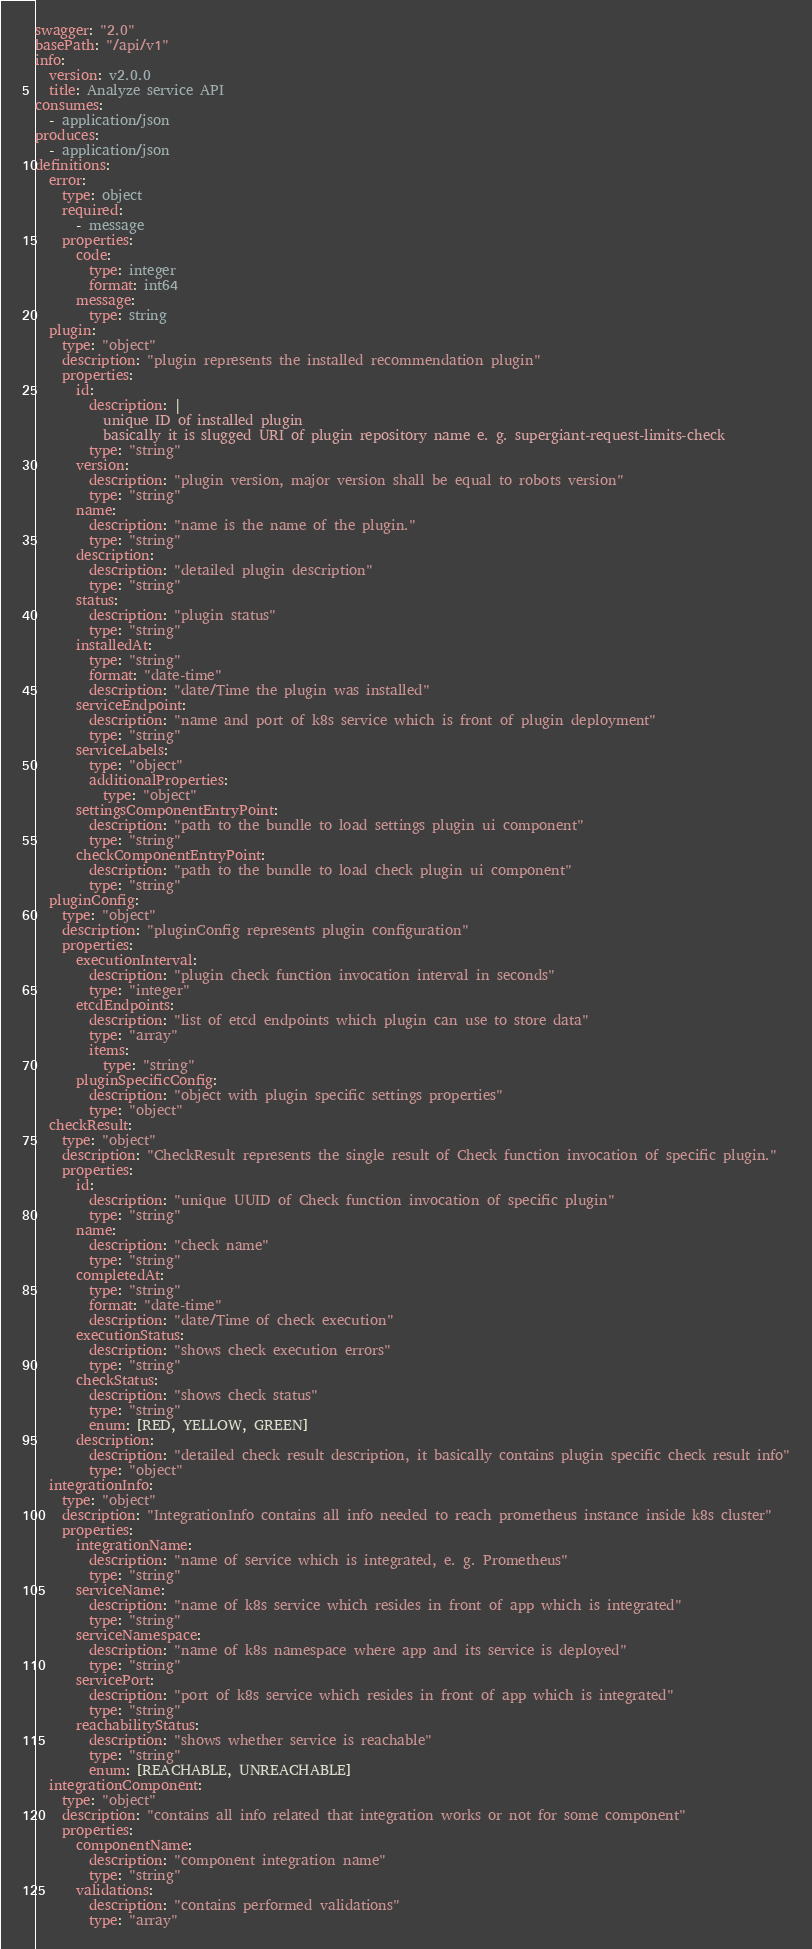<code> <loc_0><loc_0><loc_500><loc_500><_YAML_>swagger: "2.0"
basePath: "/api/v1"
info:
  version: v2.0.0
  title: Analyze service API
consumes:
  - application/json
produces:
  - application/json
definitions:
  error:
    type: object
    required:
      - message
    properties:
      code:
        type: integer
        format: int64
      message:
        type: string
  plugin:
    type: "object"
    description: "plugin represents the installed recommendation plugin"
    properties:
      id:
        description: |
          unique ID of installed plugin
          basically it is slugged URI of plugin repository name e. g. supergiant-request-limits-check
        type: "string"
      version:
        description: "plugin version, major version shall be equal to robots version"
        type: "string"
      name:
        description: "name is the name of the plugin."
        type: "string"
      description:
        description: "detailed plugin description"
        type: "string"
      status:
        description: "plugin status"
        type: "string"
      installedAt:
        type: "string"
        format: "date-time"
        description: "date/Time the plugin was installed"
      serviceEndpoint:
        description: "name and port of k8s service which is front of plugin deployment"
        type: "string"
      serviceLabels:
        type: "object"
        additionalProperties:
          type: "object"
      settingsComponentEntryPoint:
        description: "path to the bundle to load settings plugin ui component"
        type: "string"
      checkComponentEntryPoint:
        description: "path to the bundle to load check plugin ui component"
        type: "string"
  pluginConfig:
    type: "object"
    description: "pluginConfig represents plugin configuration"
    properties:
      executionInterval:
        description: "plugin check function invocation interval in seconds"
        type: "integer"
      etcdEndpoints:
        description: "list of etcd endpoints which plugin can use to store data"
        type: "array"
        items:
          type: "string"
      pluginSpecificConfig:
        description: "object with plugin specific settings properties"
        type: "object"
  checkResult:
    type: "object"
    description: "CheckResult represents the single result of Check function invocation of specific plugin."
    properties:
      id:
        description: "unique UUID of Check function invocation of specific plugin"
        type: "string"
      name:
        description: "check name"
        type: "string"
      completedAt:
        type: "string"
        format: "date-time"
        description: "date/Time of check execution"
      executionStatus:
        description: "shows check execution errors"
        type: "string"
      checkStatus:
        description: "shows check status"
        type: "string"
        enum: [RED, YELLOW, GREEN]
      description:
        description: "detailed check result description, it basically contains plugin specific check result info"
        type: "object"
  integrationInfo:
    type: "object"
    description: "IntegrationInfo contains all info needed to reach prometheus instance inside k8s cluster"
    properties:
      integrationName:
        description: "name of service which is integrated, e. g. Prometheus"
        type: "string"
      serviceName:
        description: "name of k8s service which resides in front of app which is integrated"
        type: "string"
      serviceNamespace:
        description: "name of k8s namespace where app and its service is deployed"
        type: "string"
      servicePort:
        description: "port of k8s service which resides in front of app which is integrated"
        type: "string"
      reachabilityStatus:
        description: "shows whether service is reachable"
        type: "string"
        enum: [REACHABLE, UNREACHABLE]
  integrationComponent:
    type: "object"
    description: "contains all info related that integration works or not for some component"
    properties:
      componentName:
        description: "component integration name"
        type: "string"
      validations:
        description: "contains performed validations"
        type: "array"</code> 